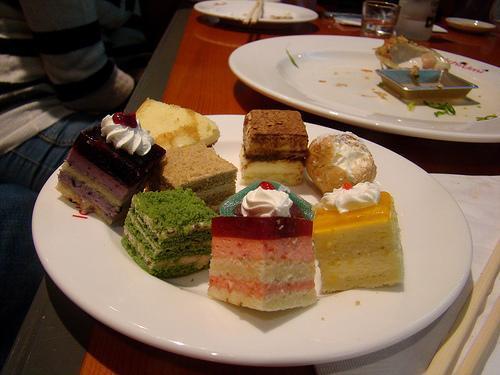How many deserts are on the nearest plate?
Give a very brief answer. 9. How many pairs of chopsticks are visible?
Give a very brief answer. 2. 